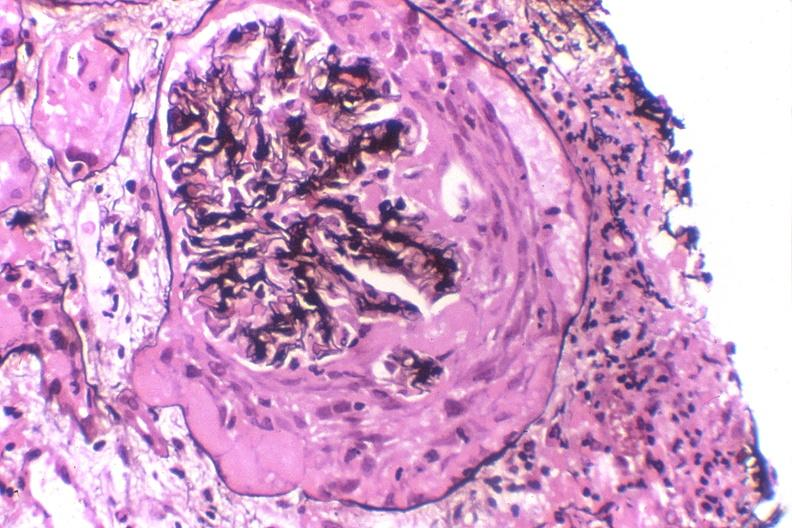what is present?
Answer the question using a single word or phrase. Urinary 